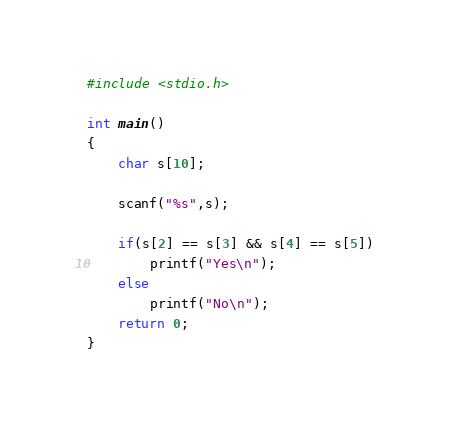<code> <loc_0><loc_0><loc_500><loc_500><_C_>#include <stdio.h>

int main()
{
	char s[10];

	scanf("%s",s);

	if(s[2] == s[3] && s[4] == s[5])
		printf("Yes\n");
	else
		printf("No\n");
	return 0;
}</code> 